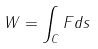Convert formula to latex. <formula><loc_0><loc_0><loc_500><loc_500>W = \int _ { C } F d s</formula> 